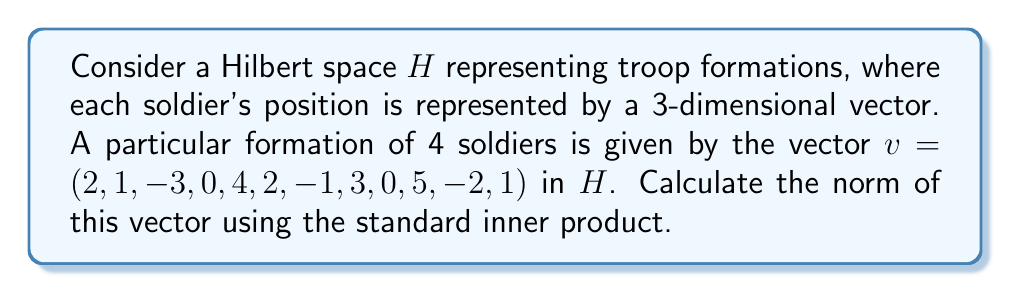Teach me how to tackle this problem. Let's approach this step-by-step:

1) In a Hilbert space, the norm of a vector $v$ is defined as the square root of the inner product of the vector with itself:

   $\|v\| = \sqrt{\langle v, v \rangle}$

2) For our vector $v = (2, 1, -3, 0, 4, 2, -1, 3, 0, 5, -2, 1)$, we need to calculate $\langle v, v \rangle$.

3) In this case, the inner product is simply the sum of the squares of each component:

   $\langle v, v \rangle = 2^2 + 1^2 + (-3)^2 + 0^2 + 4^2 + 2^2 + (-1)^2 + 3^2 + 0^2 + 5^2 + (-2)^2 + 1^2$

4) Let's calculate each term:
   
   $4 + 1 + 9 + 0 + 16 + 4 + 1 + 9 + 0 + 25 + 4 + 1$

5) Sum these up:
   
   $4 + 1 + 9 + 0 + 16 + 4 + 1 + 9 + 0 + 25 + 4 + 1 = 74$

6) Now, we take the square root of this sum:

   $\|v\| = \sqrt{74}$

This gives us the norm of the vector representing the troop formation.
Answer: $\|v\| = \sqrt{74}$ 